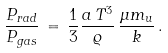Convert formula to latex. <formula><loc_0><loc_0><loc_500><loc_500>\frac { P _ { r a d } } { P _ { g a s } } \, = \, \frac { 1 } { 3 } \frac { a \, T ^ { 3 } } { \varrho } \, \frac { \mu m _ { u } } { k } \, .</formula> 